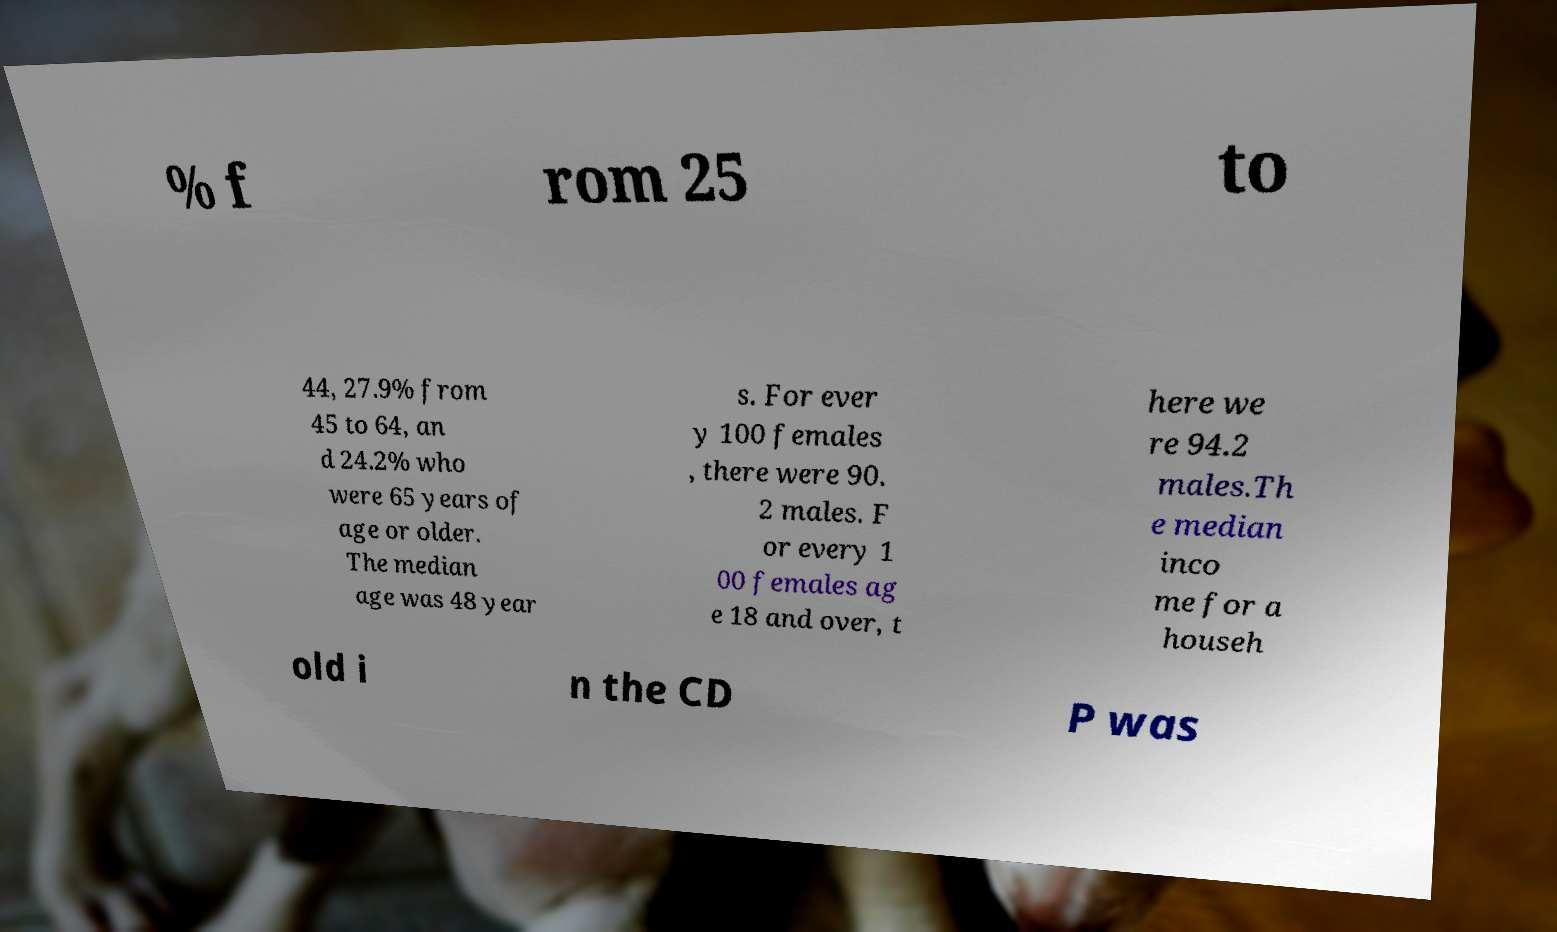Could you assist in decoding the text presented in this image and type it out clearly? % f rom 25 to 44, 27.9% from 45 to 64, an d 24.2% who were 65 years of age or older. The median age was 48 year s. For ever y 100 females , there were 90. 2 males. F or every 1 00 females ag e 18 and over, t here we re 94.2 males.Th e median inco me for a househ old i n the CD P was 